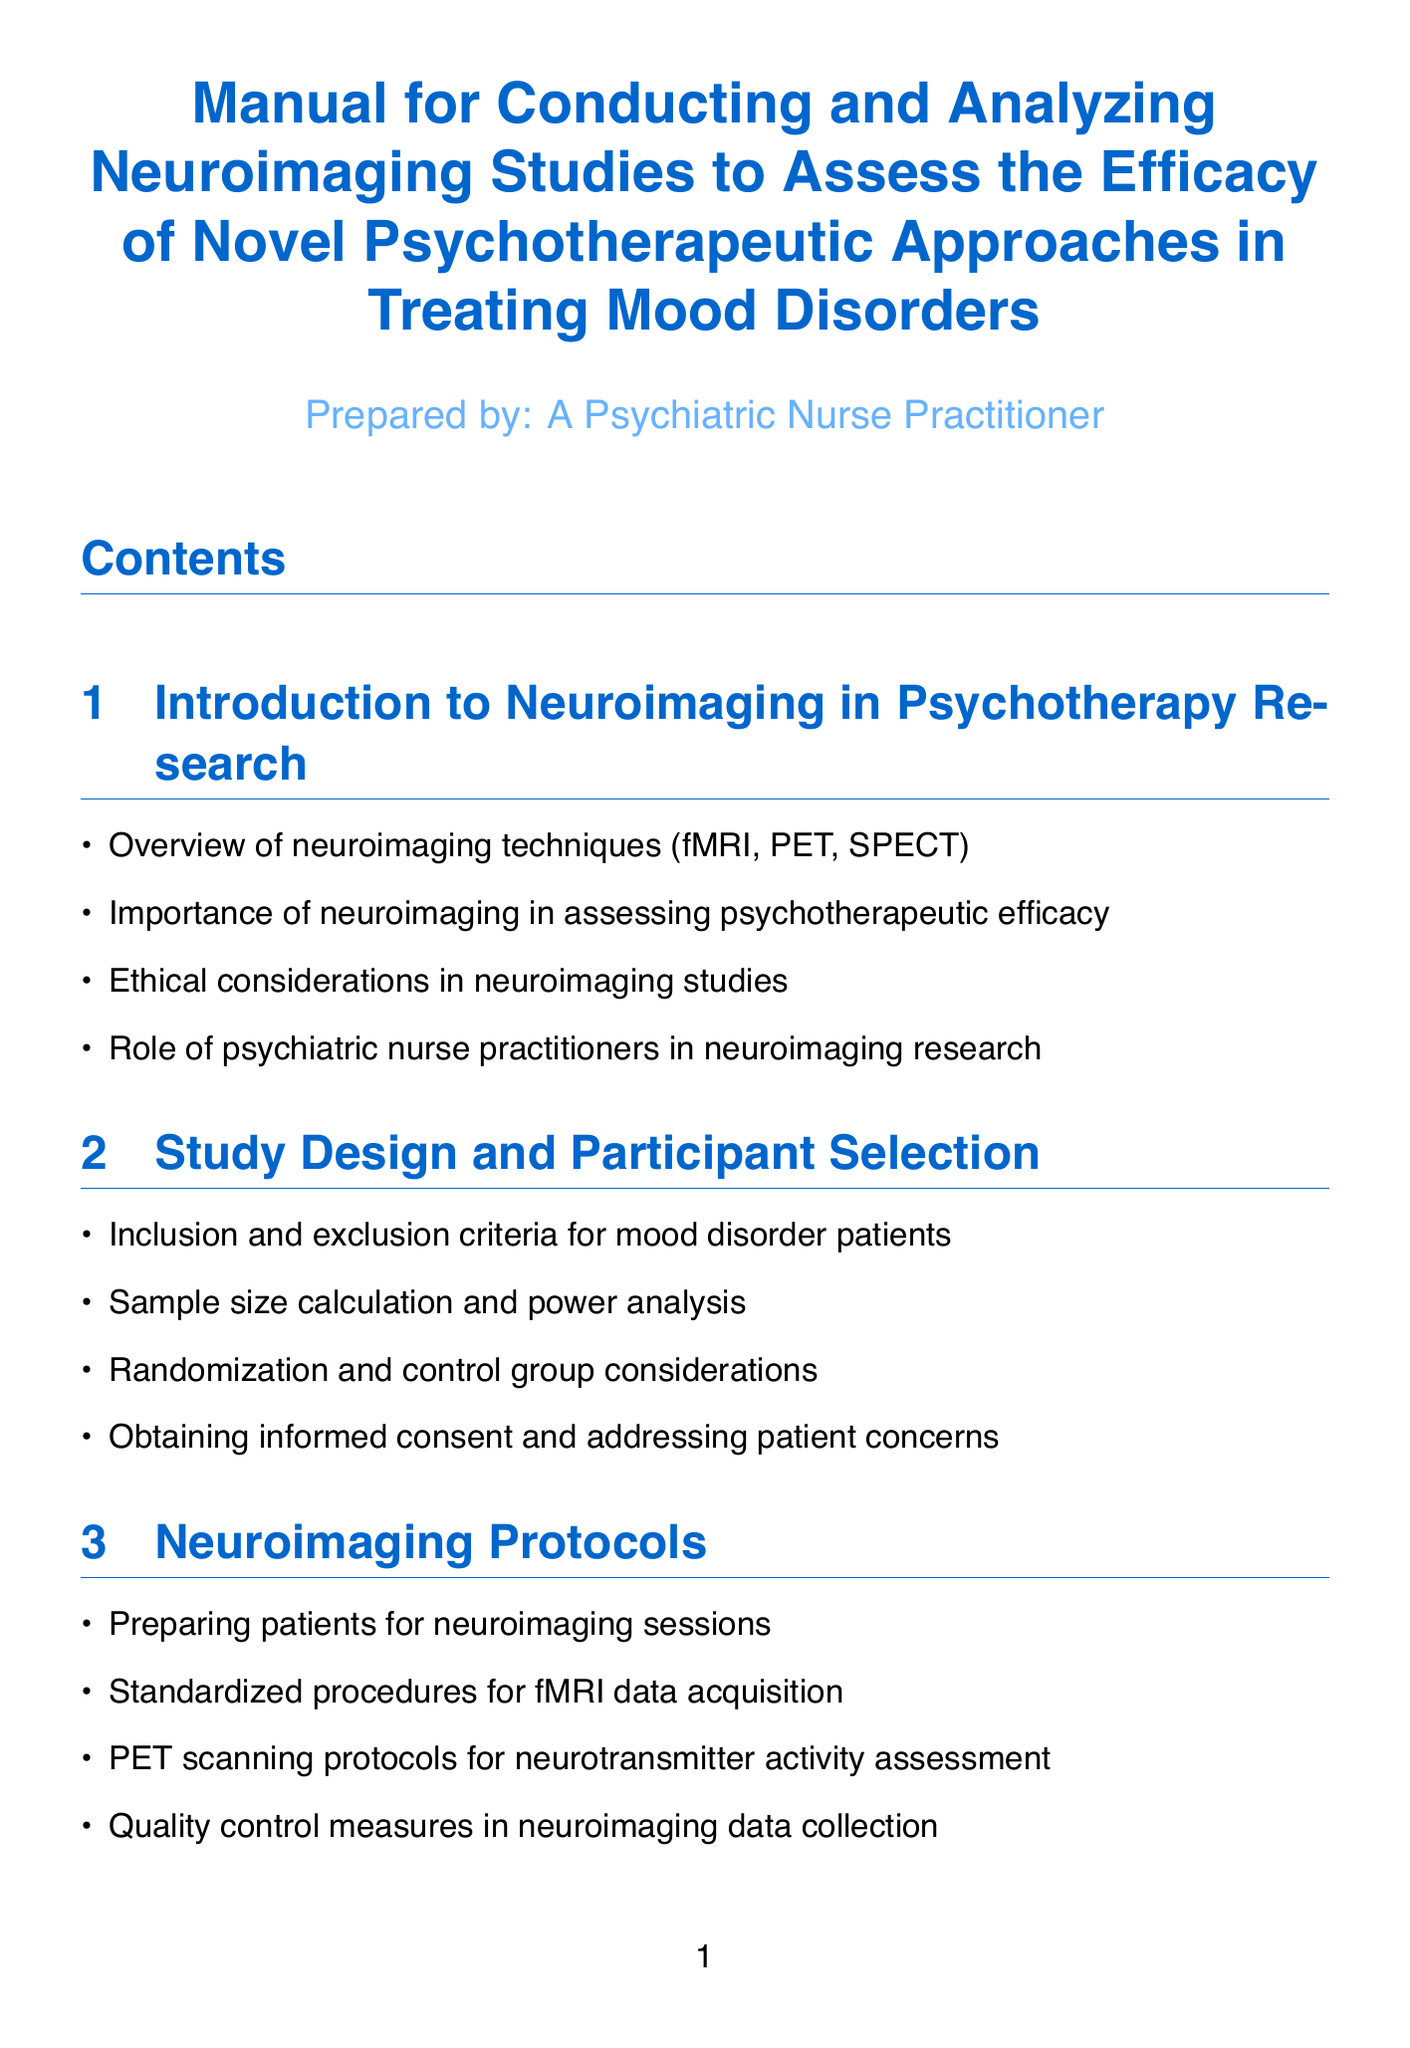What are the neuroimaging techniques mentioned? The document lists various neuroimaging techniques including fMRI, PET, and SPECT.
Answer: fMRI, PET, SPECT What is assessed by neuroimaging in psychotherapy research? The document highlights the importance of neuroimaging in assessing psychotherapeutic efficacy.
Answer: Psychotherapeutic efficacy Which therapy is used for bipolar disorder? The document specifies Interpersonal and Social Rhythm Therapy as the therapy for bipolar disorder.
Answer: Interpersonal and Social Rhythm Therapy What statistical analysis technique is used for fMRI data? The document mentions General Linear Model (GLM) and Multivariate Pattern Analysis (MVPA) as statistical techniques for analyzing fMRI data.
Answer: GLM, MVPA What does SPM12 stand for? The document introduces SPM12 as Statistical Parametric Mapping, a software for neuroimaging data processing.
Answer: Statistical Parametric Mapping How many recommended reading titles are listed? The document provides a count of the recommended reading titles, which total three.
Answer: Three What are the ethical considerations mentioned in relation to neuroimaging? The document discusses ethical considerations in neuroimaging studies, including issues related to consent and data publication.
Answer: Consent, data publication What is one potential future direction mentioned for neuroimaging? The document suggests the integration of machine learning as a future direction for neuroimaging analysis.
Answer: Machine learning What does ACT stand for? In the context of the document, ACT refers to Acceptance and Commitment Therapy, a novel psychotherapeutic approach.
Answer: Acceptance and Commitment Therapy 